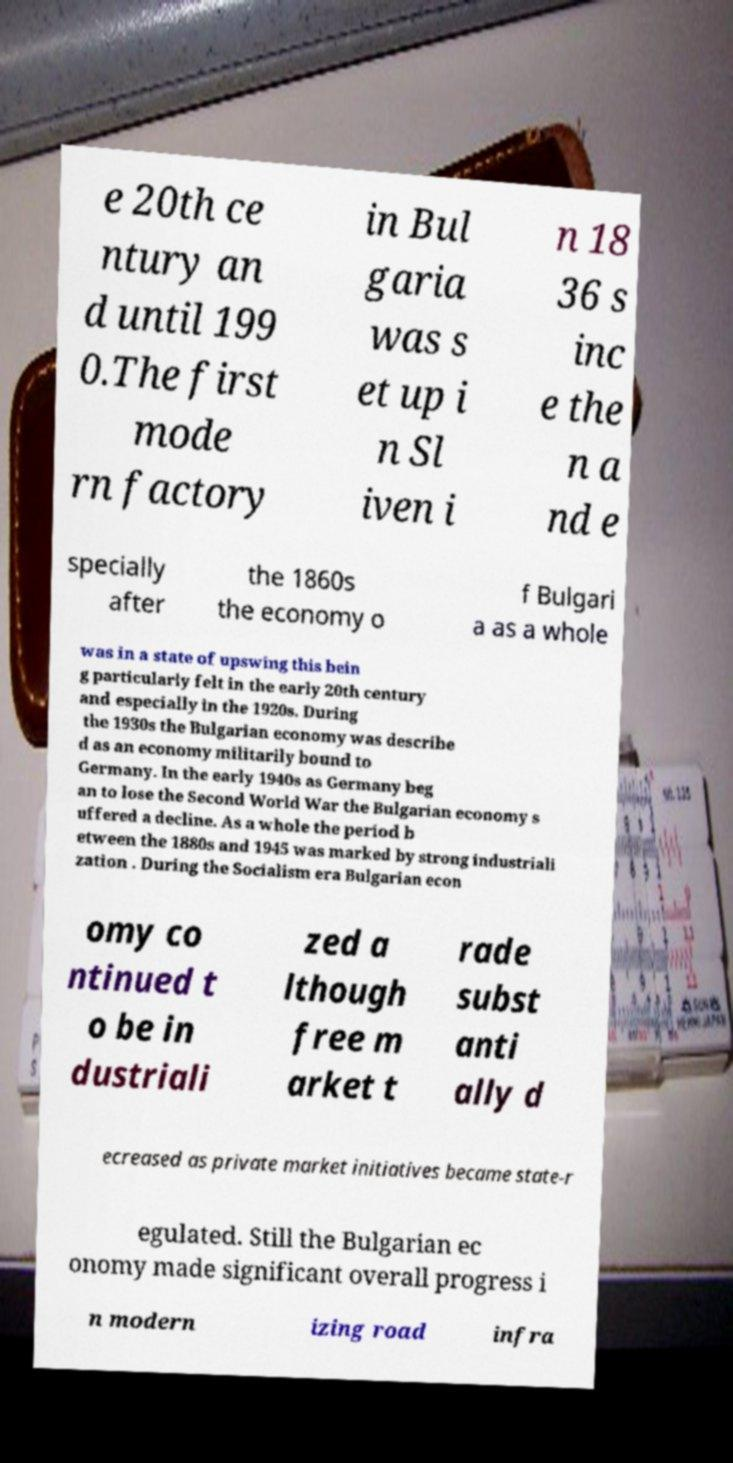Please read and relay the text visible in this image. What does it say? e 20th ce ntury an d until 199 0.The first mode rn factory in Bul garia was s et up i n Sl iven i n 18 36 s inc e the n a nd e specially after the 1860s the economy o f Bulgari a as a whole was in a state of upswing this bein g particularly felt in the early 20th century and especially in the 1920s. During the 1930s the Bulgarian economy was describe d as an economy militarily bound to Germany. In the early 1940s as Germany beg an to lose the Second World War the Bulgarian economy s uffered a decline. As a whole the period b etween the 1880s and 1945 was marked by strong industriali zation . During the Socialism era Bulgarian econ omy co ntinued t o be in dustriali zed a lthough free m arket t rade subst anti ally d ecreased as private market initiatives became state-r egulated. Still the Bulgarian ec onomy made significant overall progress i n modern izing road infra 